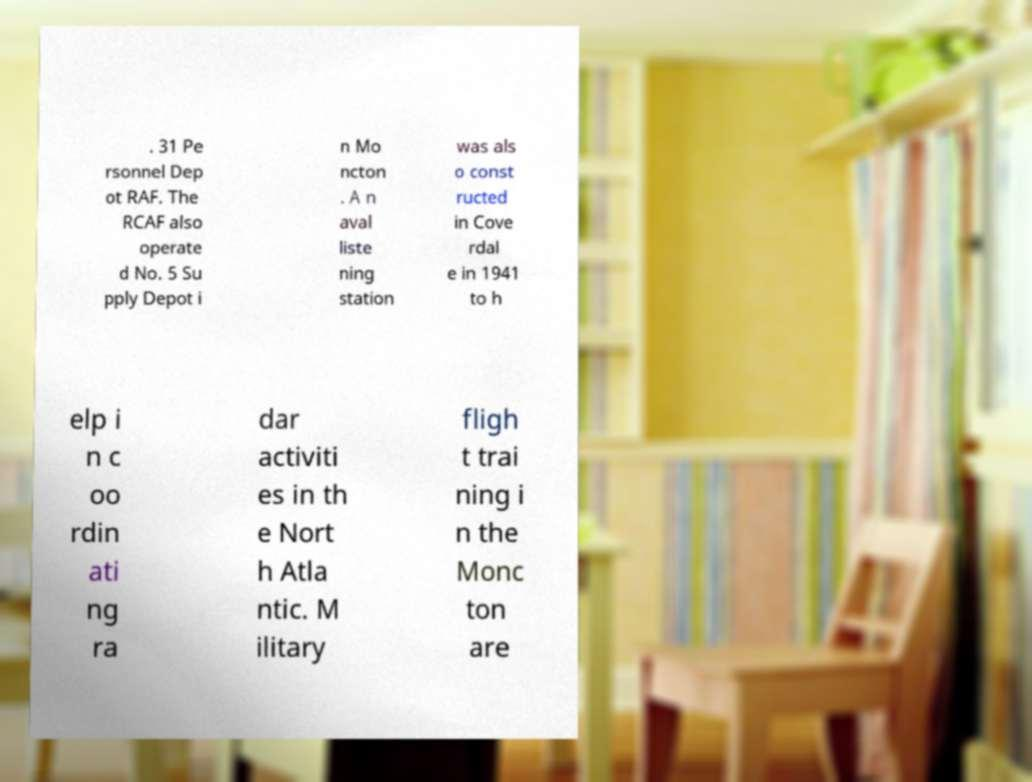What messages or text are displayed in this image? I need them in a readable, typed format. . 31 Pe rsonnel Dep ot RAF. The RCAF also operate d No. 5 Su pply Depot i n Mo ncton . A n aval liste ning station was als o const ructed in Cove rdal e in 1941 to h elp i n c oo rdin ati ng ra dar activiti es in th e Nort h Atla ntic. M ilitary fligh t trai ning i n the Monc ton are 